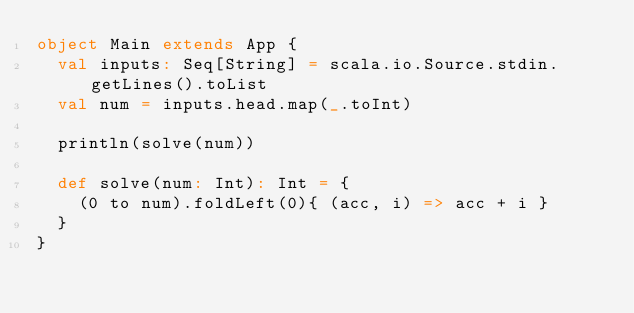<code> <loc_0><loc_0><loc_500><loc_500><_Scala_>object Main extends App {
  val inputs: Seq[String] = scala.io.Source.stdin.getLines().toList
  val num = inputs.head.map(_.toInt)

  println(solve(num))

  def solve(num: Int): Int = {
    (0 to num).foldLeft(0){ (acc, i) => acc + i }
  }
}</code> 